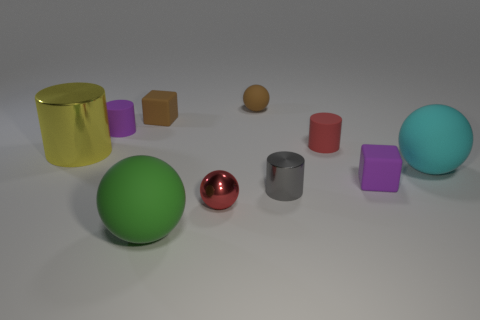What number of other things are there of the same size as the red metal thing?
Keep it short and to the point. 6. What number of big purple rubber cubes are there?
Your answer should be very brief. 0. Does the small purple object on the right side of the tiny gray metal cylinder have the same material as the red thing that is behind the red metal sphere?
Provide a short and direct response. Yes. What is the material of the yellow thing?
Keep it short and to the point. Metal. How many cyan spheres are the same material as the big cylinder?
Your answer should be very brief. 0. How many rubber things are either tiny purple things or cyan things?
Keep it short and to the point. 3. There is a big matte thing right of the big green ball; is it the same shape as the tiny purple object that is to the left of the brown cube?
Offer a terse response. No. The cylinder that is to the left of the brown sphere and in front of the red matte cylinder is what color?
Your answer should be compact. Yellow. There is a cube in front of the red cylinder; does it have the same size as the brown rubber thing on the left side of the red ball?
Your answer should be very brief. Yes. How many large spheres have the same color as the small rubber sphere?
Keep it short and to the point. 0. 